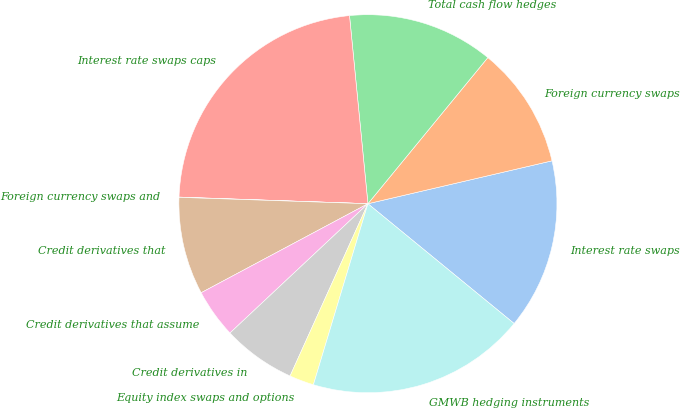<chart> <loc_0><loc_0><loc_500><loc_500><pie_chart><fcel>Interest rate swaps<fcel>Foreign currency swaps<fcel>Total cash flow hedges<fcel>Interest rate swaps caps<fcel>Foreign currency swaps and<fcel>Credit derivatives that<fcel>Credit derivatives that assume<fcel>Credit derivatives in<fcel>Equity index swaps and options<fcel>GMWB hedging instruments<nl><fcel>14.57%<fcel>10.42%<fcel>12.49%<fcel>22.89%<fcel>0.02%<fcel>8.34%<fcel>4.18%<fcel>6.26%<fcel>2.1%<fcel>18.73%<nl></chart> 